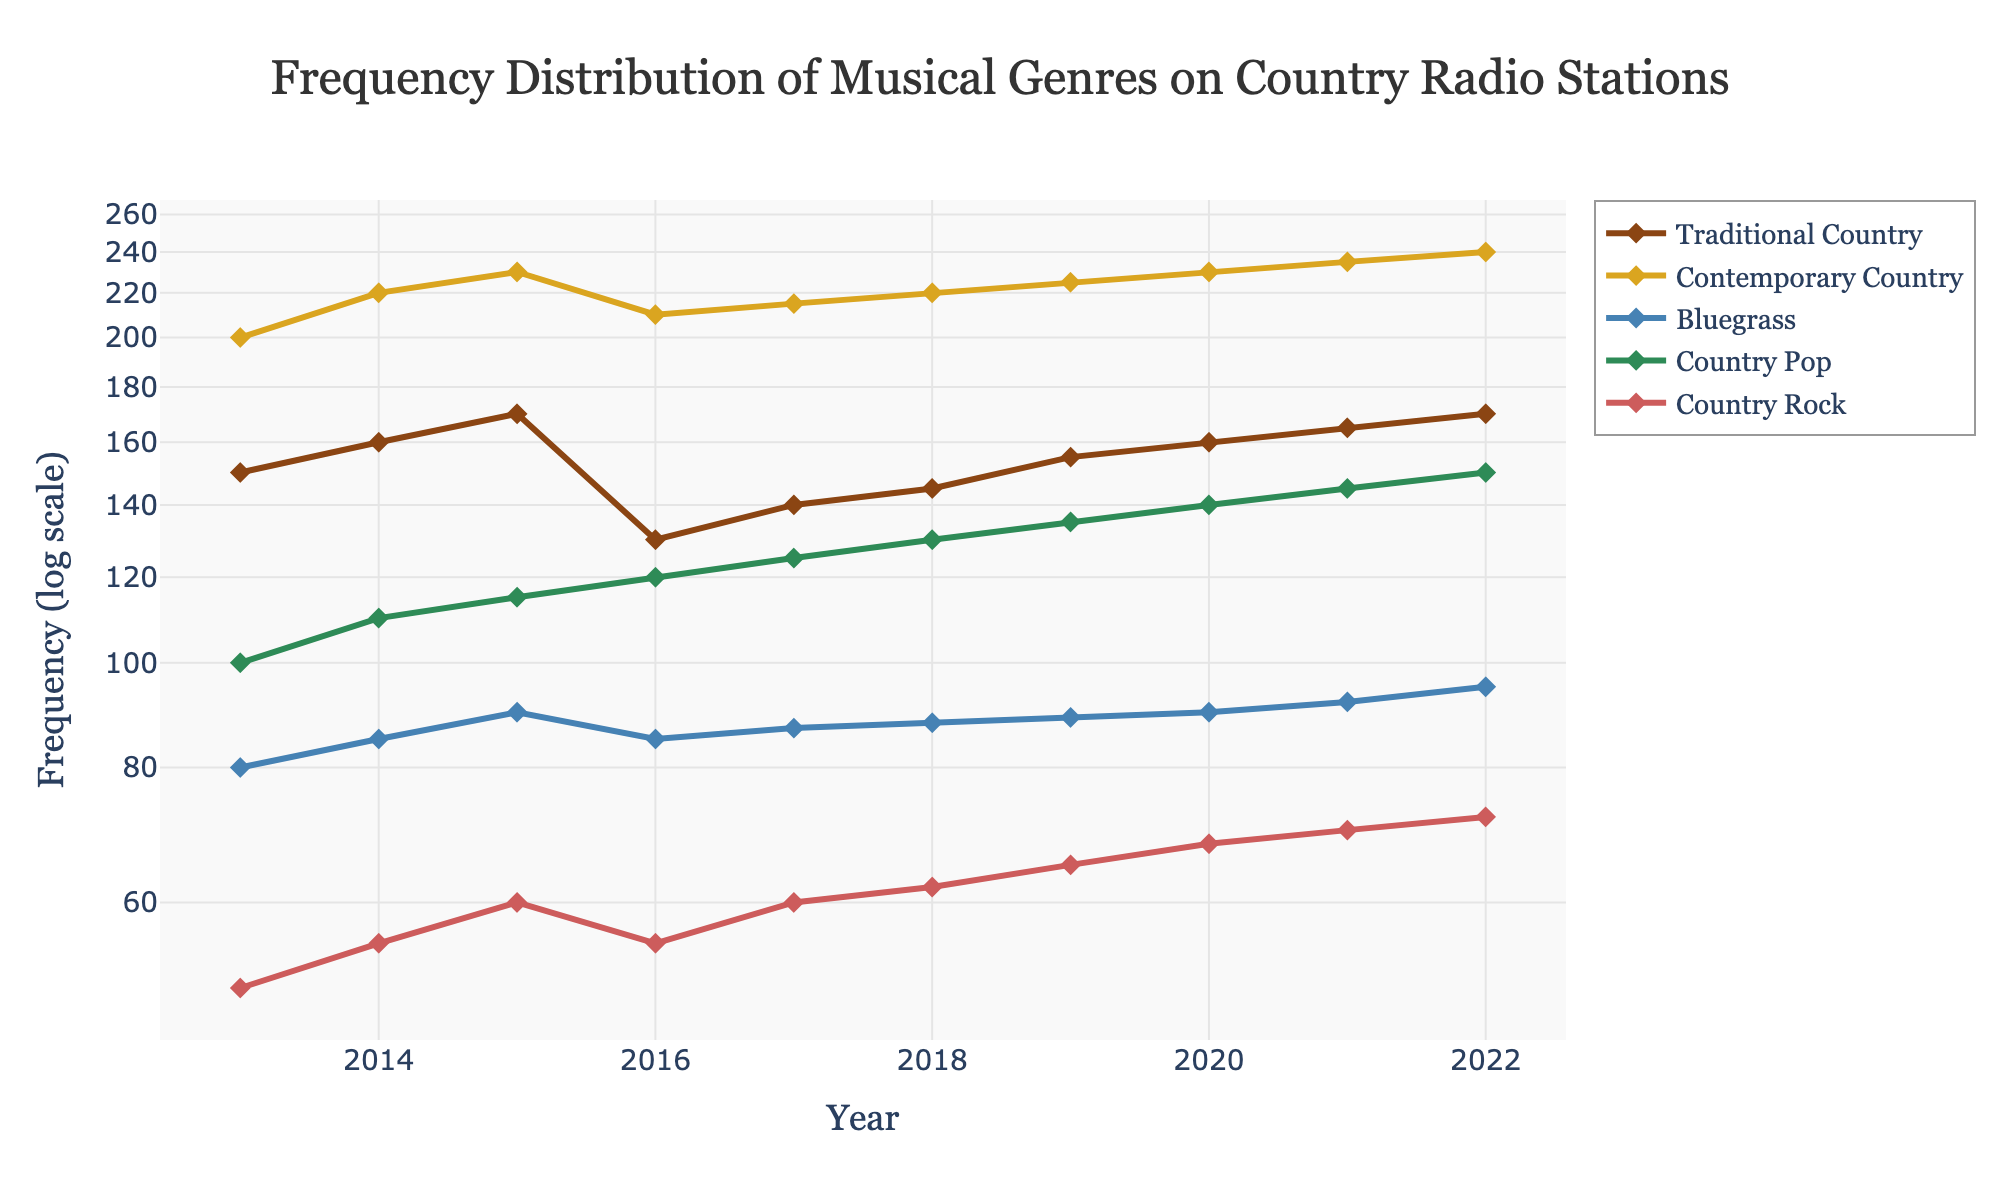What is the range of years shown on the x-axis? The x-axis spans from the year 2013 to 2022. This range can be determined by observing the marks at the lower and upper ends of the x-axis.
Answer: 2013 to 2022 What is the title of the plot? The title is located at the top center of the figure, typically in a larger and bolder font. It reads "Frequency Distribution of Musical Genres on Country Radio Stations".
Answer: Frequency Distribution of Musical Genres on Country Radio Stations Which genre has the highest frequency in the year 2022? By observing the data points for the year 2022, we see that Contemporary Country has the highest value in the y-axis among the plotted points.
Answer: Contemporary Country What is the frequency of Bluegrass in 2013? The frequency can be found by locating the Bluegrass line at the year 2013 on the x-axis and reading its corresponding y-value. The data point is at 80.
Answer: 80 Which genre experienced the most noticeable drop in frequency between 2015 and 2016? To determine this, compare the vertical distance between the data points for each genre from 2015 to 2016. Traditional Country shows a significant drop from 170 to 130.
Answer: Traditional Country What is the total frequency of Country Pop from 2018 to 2022? Sum the individual frequency values for Country Pop from the years 2018, 2019, 2020, 2021, and 2022: 130 + 135 + 140 + 145 + 150 = 700.
Answer: 700 Which genre has the highest average frequency over the entire period? Calculate the average by summing the frequencies for each genre over the years and dividing by the number of years. Contemporary Country has the highest values across the years leading to a highest average.
Answer: Contemporary Country How does the log scale affect the perception of fluctuations in the frequency data? A logarithmic scale compresses larger values, making differences appear smaller, and expands smaller values, making differences appear larger. This can make it easier to compare growth rates across a wide range of values.
Answer: Compresses large values, expands small values 